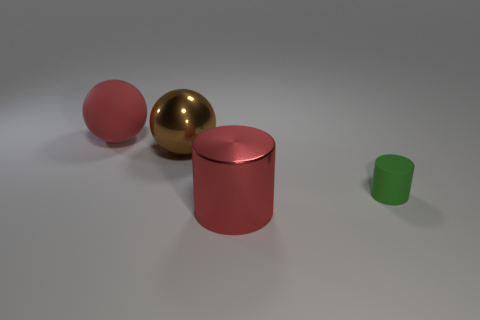Add 4 green cylinders. How many objects exist? 8 Subtract all small yellow spheres. Subtract all brown metallic balls. How many objects are left? 3 Add 1 balls. How many balls are left? 3 Add 1 big brown spheres. How many big brown spheres exist? 2 Subtract 0 yellow spheres. How many objects are left? 4 